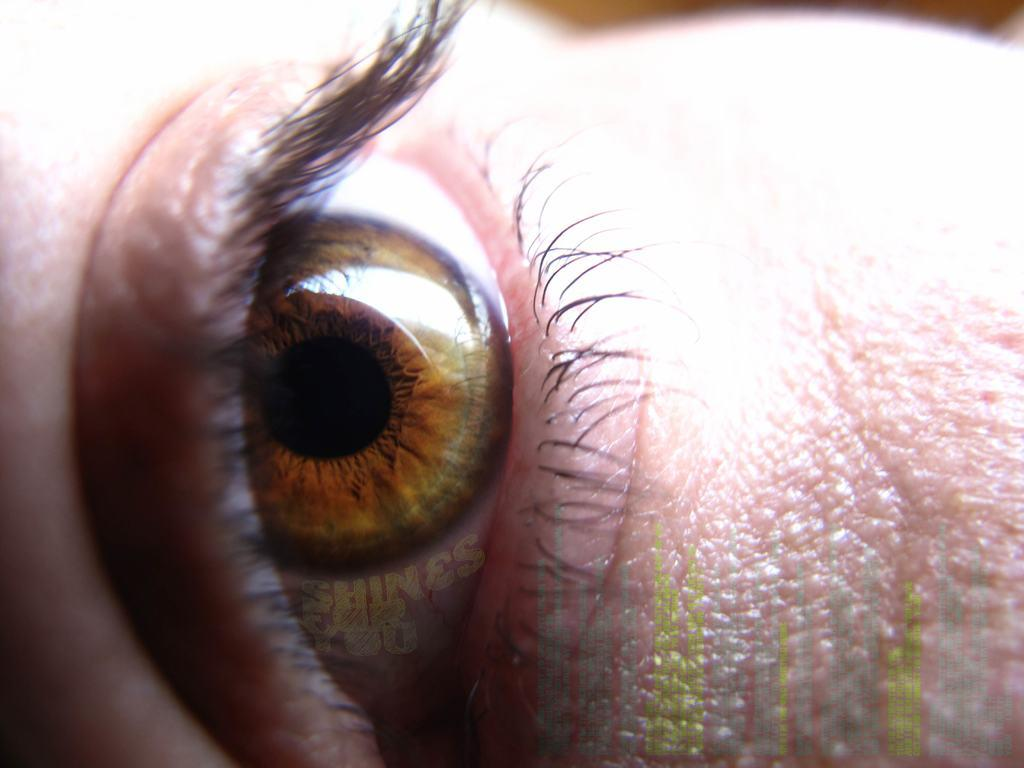What is the main subject of the image? The main subject of the image is the eye of a person. Can you describe the eye in the image? The eye appears to be open and has a visible iris and pupil. What type of plane is being written on in the image? There is no plane or writing present in the image; it only features the eye of a person. 